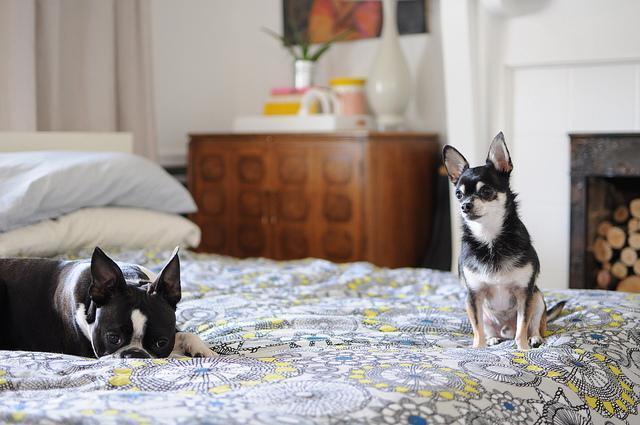How many dogs are on the bed?
Give a very brief answer. 2. How many pillows are on the bed?
Give a very brief answer. 2. How many beds are in the photo?
Give a very brief answer. 1. How many dogs are there?
Give a very brief answer. 3. How many people are here?
Give a very brief answer. 0. 